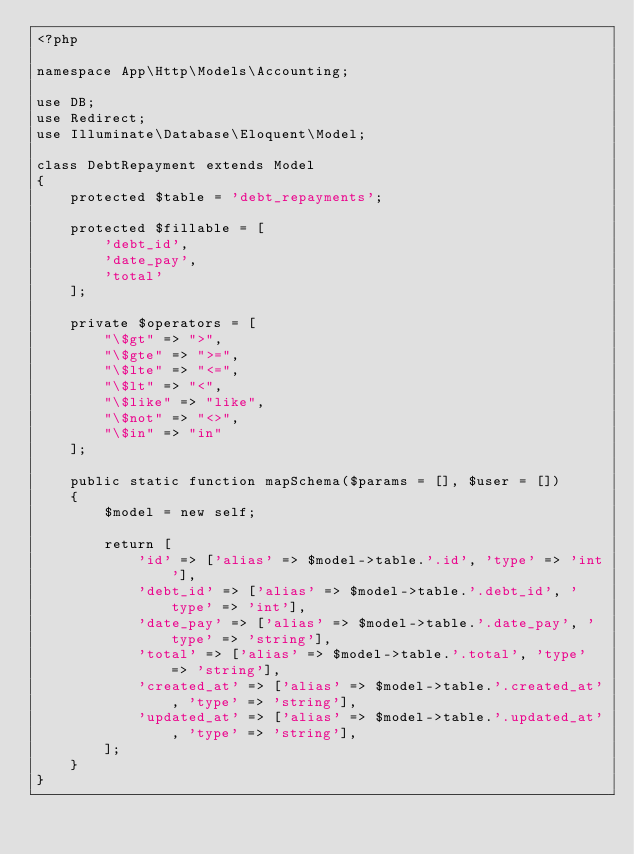Convert code to text. <code><loc_0><loc_0><loc_500><loc_500><_PHP_><?php

namespace App\Http\Models\Accounting;

use DB;
use Redirect;
use Illuminate\Database\Eloquent\Model;

class DebtRepayment extends Model
{
	protected $table = 'debt_repayments';

	protected $fillable = [
        'debt_id',
        'date_pay',
        'total'
    ];

    private $operators = [
        "\$gt" => ">",
        "\$gte" => ">=",
        "\$lte" => "<=",
        "\$lt" => "<",
        "\$like" => "like",
        "\$not" => "<>",
        "\$in" => "in"
    ];
    
    public static function mapSchema($params = [], $user = [])
    {
        $model = new self;

        return [
            'id' => ['alias' => $model->table.'.id', 'type' => 'int'],
            'debt_id' => ['alias' => $model->table.'.debt_id', 'type' => 'int'],
            'date_pay' => ['alias' => $model->table.'.date_pay', 'type' => 'string'],
            'total' => ['alias' => $model->table.'.total', 'type' => 'string'],
            'created_at' => ['alias' => $model->table.'.created_at', 'type' => 'string'],
            'updated_at' => ['alias' => $model->table.'.updated_at', 'type' => 'string'],
        ];
    }
}</code> 